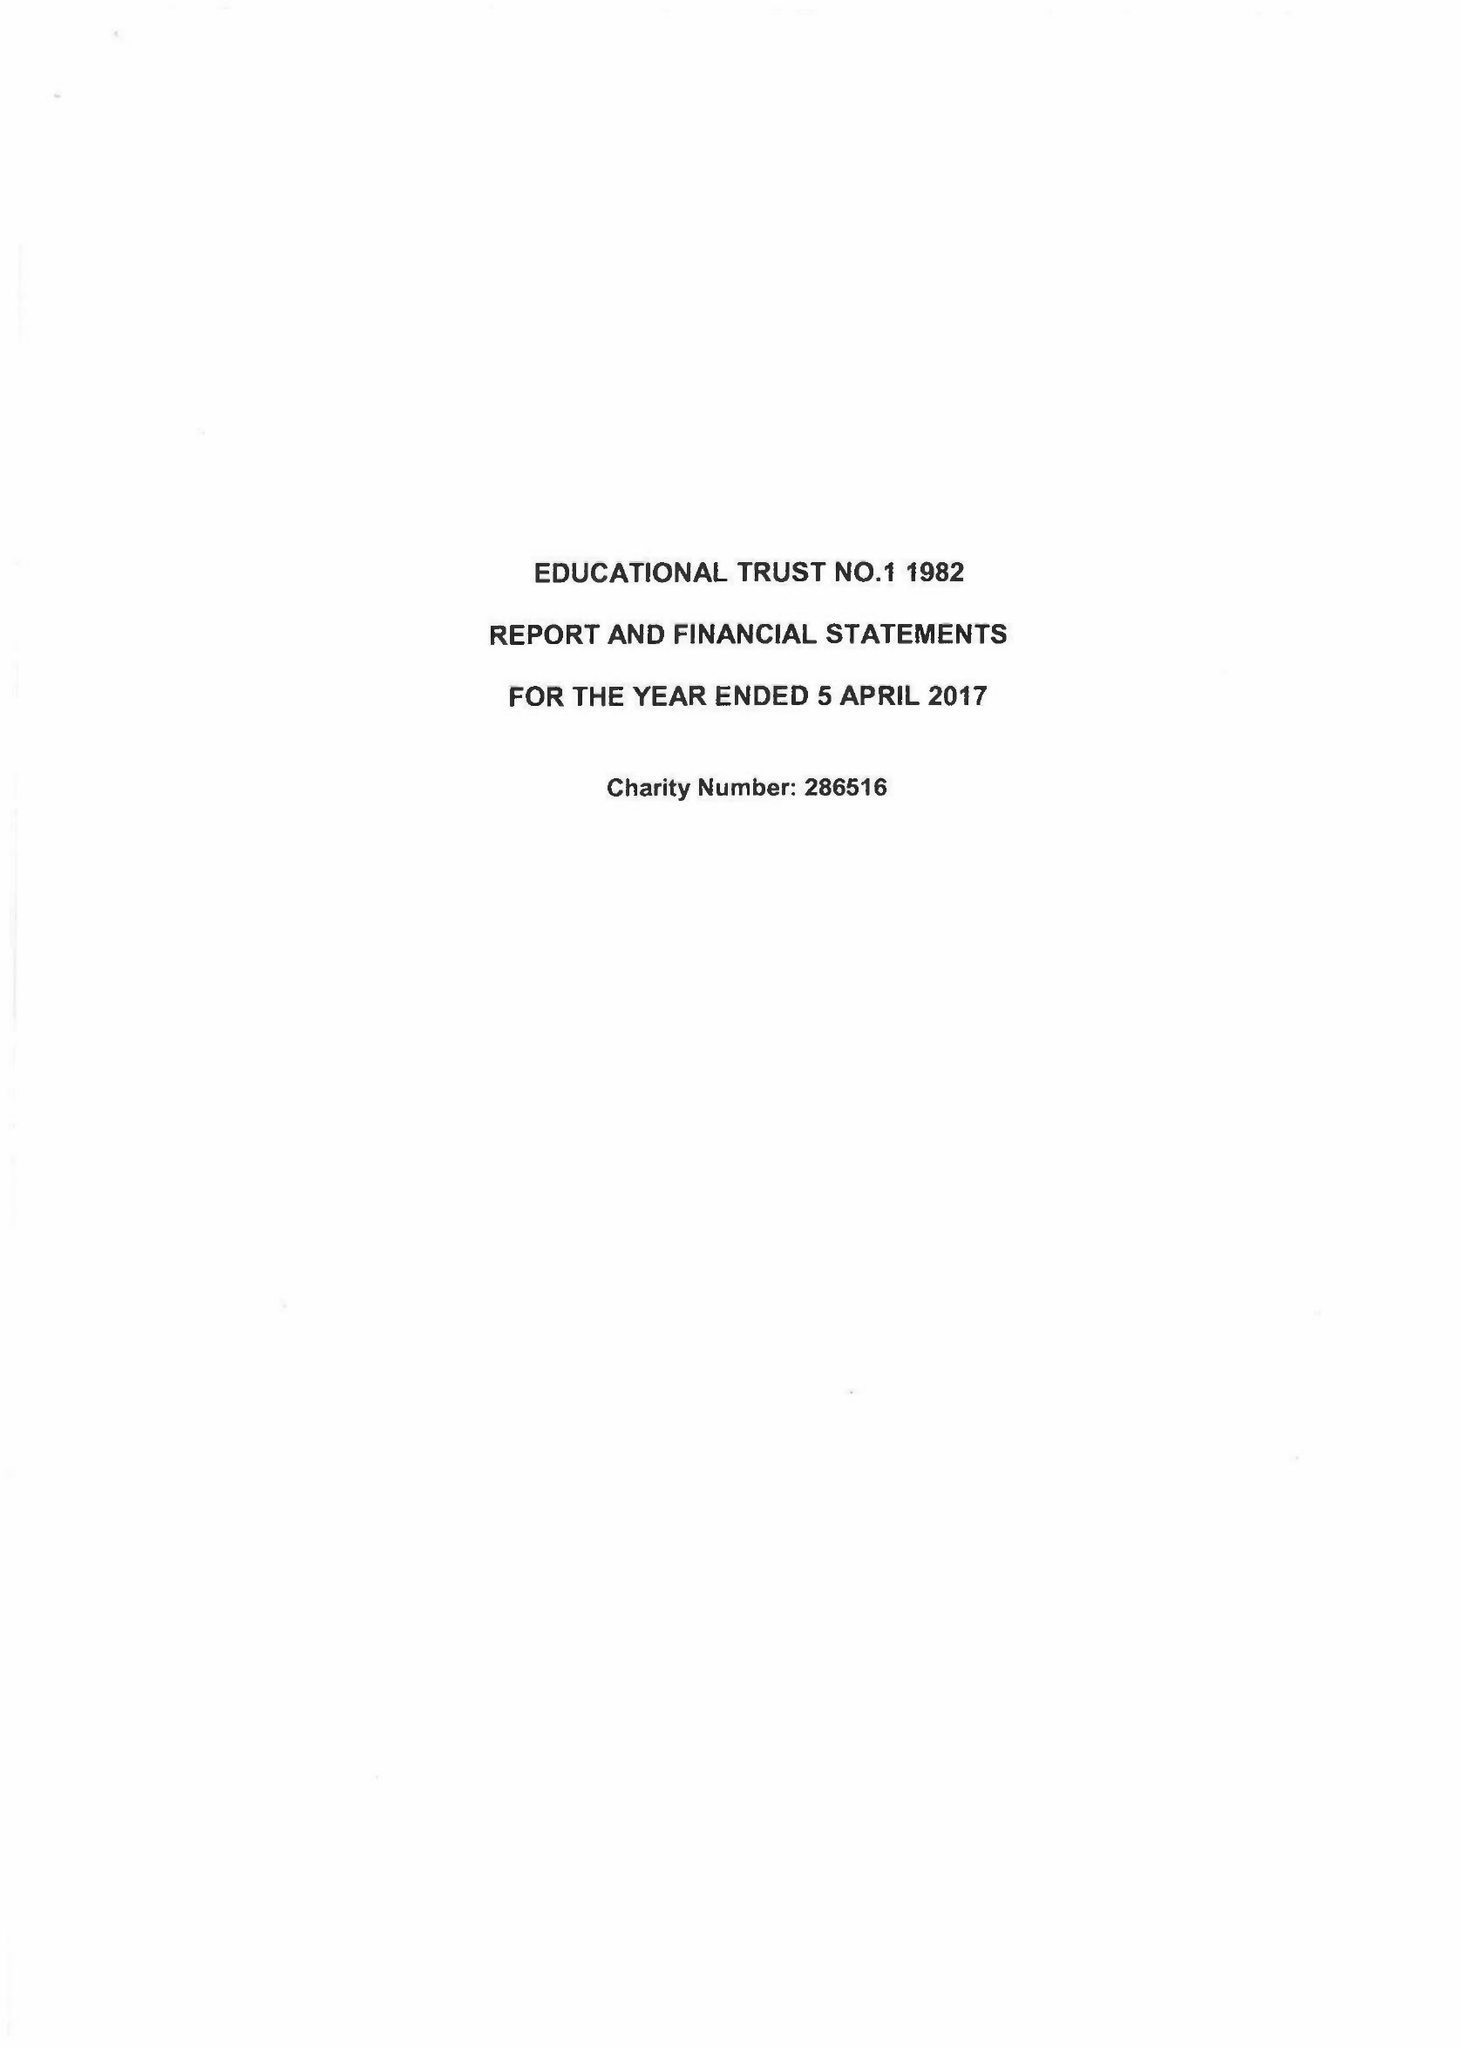What is the value for the charity_name?
Answer the question using a single word or phrase. Educational Trust No. 1 1982 